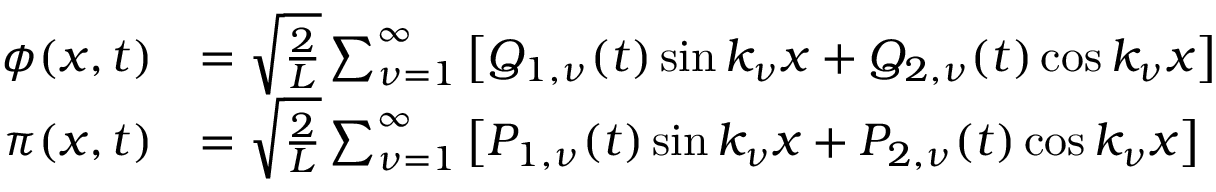Convert formula to latex. <formula><loc_0><loc_0><loc_500><loc_500>\begin{array} { r l } { \phi ( x , t ) } & { = \sqrt { \frac { 2 } { L } } \sum _ { \nu = 1 } ^ { \infty } \left [ Q _ { 1 , \nu } ( t ) \sin k _ { \nu } x + Q _ { 2 , \nu } ( t ) \cos k _ { \nu } x \right ] } \\ { \pi ( x , t ) } & { = \sqrt { \frac { 2 } { L } } \sum _ { \nu = 1 } ^ { \infty } \left [ P _ { 1 , \nu } ( t ) \sin k _ { \nu } x + P _ { 2 , \nu } ( t ) \cos k _ { \nu } x \right ] } \end{array}</formula> 